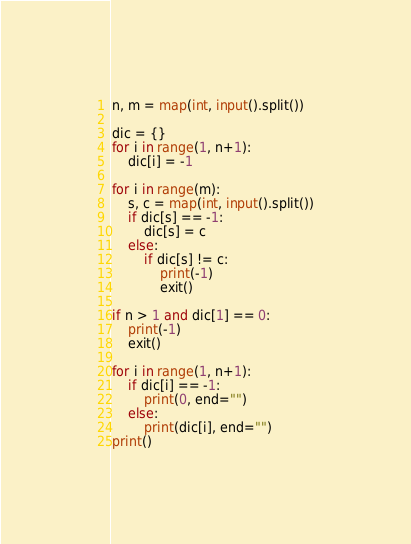Convert code to text. <code><loc_0><loc_0><loc_500><loc_500><_Python_>n, m = map(int, input().split())

dic = {}
for i in range(1, n+1):
    dic[i] = -1

for i in range(m):
    s, c = map(int, input().split())
    if dic[s] == -1:
        dic[s] = c
    else:
        if dic[s] != c:
            print(-1)
            exit()

if n > 1 and dic[1] == 0:
    print(-1)
    exit()

for i in range(1, n+1):
    if dic[i] == -1:
        print(0, end="")
    else:
        print(dic[i], end="")
print()
</code> 